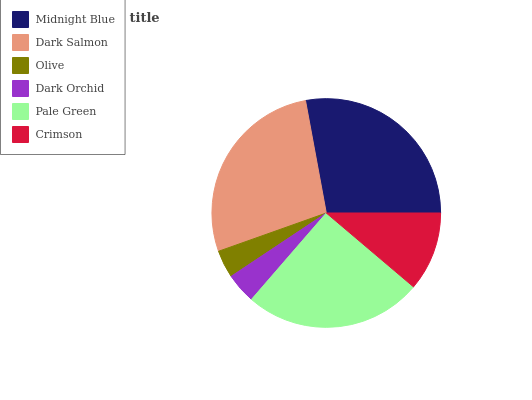Is Olive the minimum?
Answer yes or no. Yes. Is Midnight Blue the maximum?
Answer yes or no. Yes. Is Dark Salmon the minimum?
Answer yes or no. No. Is Dark Salmon the maximum?
Answer yes or no. No. Is Midnight Blue greater than Dark Salmon?
Answer yes or no. Yes. Is Dark Salmon less than Midnight Blue?
Answer yes or no. Yes. Is Dark Salmon greater than Midnight Blue?
Answer yes or no. No. Is Midnight Blue less than Dark Salmon?
Answer yes or no. No. Is Pale Green the high median?
Answer yes or no. Yes. Is Crimson the low median?
Answer yes or no. Yes. Is Olive the high median?
Answer yes or no. No. Is Olive the low median?
Answer yes or no. No. 